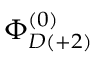Convert formula to latex. <formula><loc_0><loc_0><loc_500><loc_500>\Phi _ { D ( + 2 ) } ^ { ( 0 ) }</formula> 